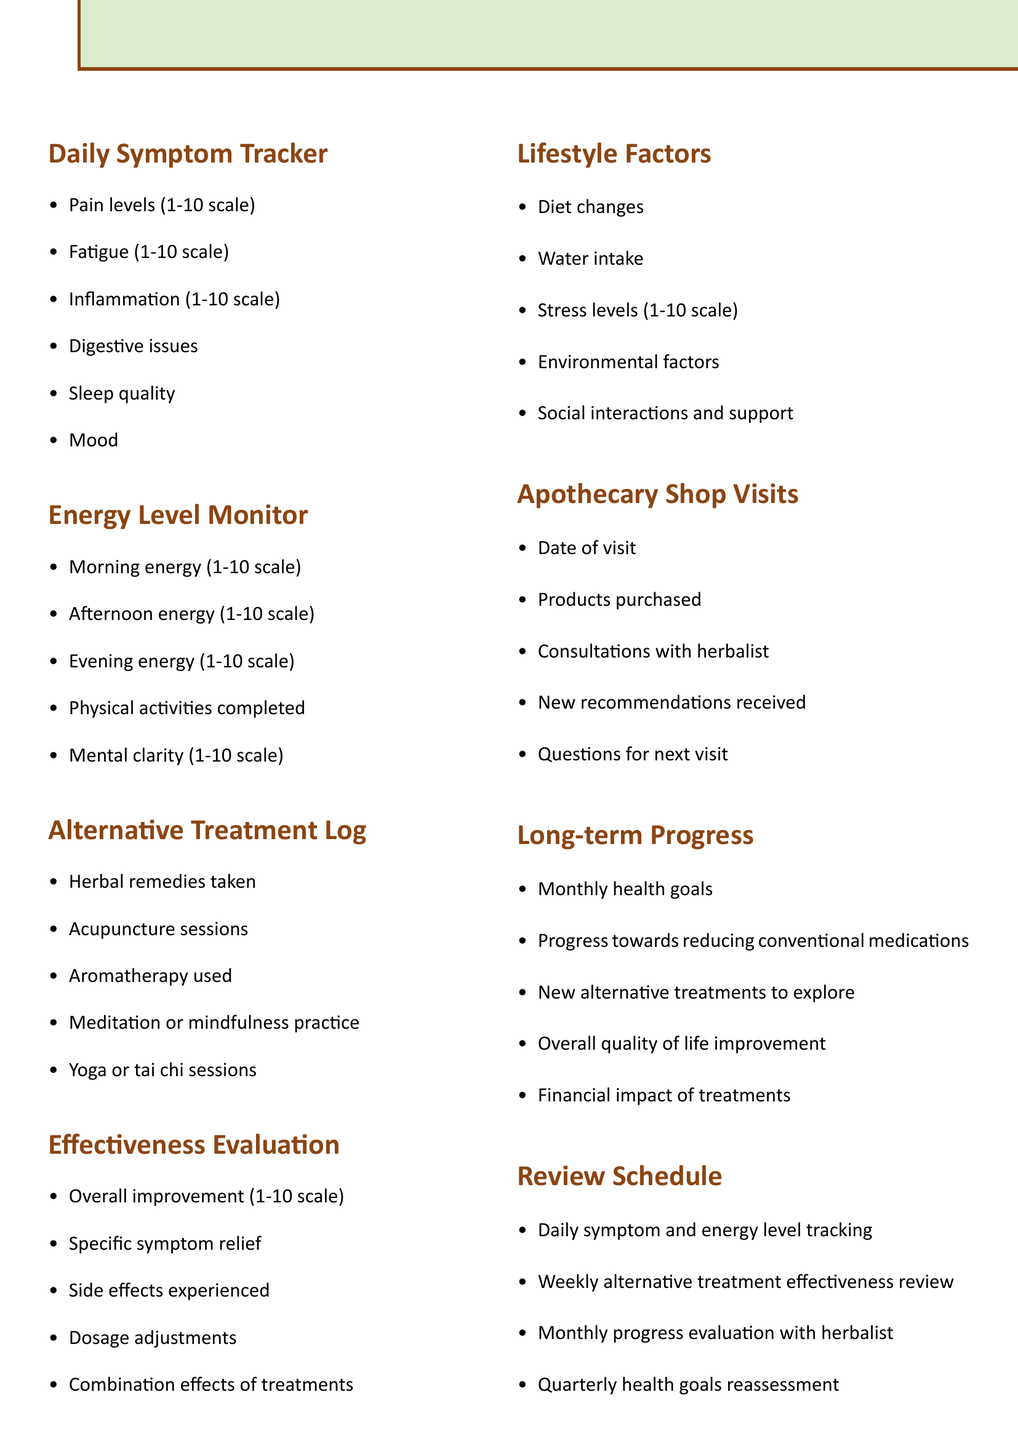What are the items tracked in the Daily Symptom Tracker? This section lists the specific symptoms that need to be monitored daily.
Answer: Pain levels, Fatigue, Inflammation, Digestive issues, Sleep quality, Mood How many categories are listed under the Energy Level Monitor? The Energy Level Monitor includes five specific items that track energy levels throughout the day.
Answer: 5 What is the purpose of the Effectiveness Evaluation section? This section is designed to assess how well the alternative treatments are working over time.
Answer: To evaluate effectiveness What is the frequency of the review schedule for alternative treatment effectiveness? The review schedule indicates that this evaluation occurs weekly.
Answer: Weekly What type of resources are included in the document? The resources section lists various guides, libraries, support groups, forums, and apps relevant to alternative treatments.
Answer: Herbal guide, Integrative Medicine Library, support group, online forums, symptom tracking apps 